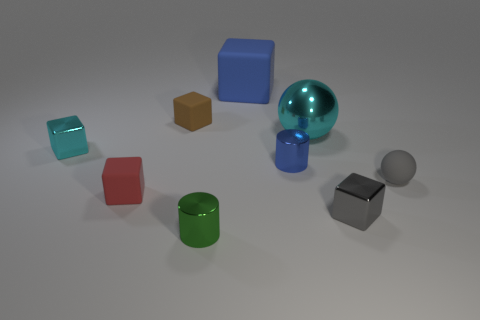What number of other things are the same shape as the tiny green object?
Provide a short and direct response. 1. Are there any other things that have the same color as the tiny ball?
Your answer should be compact. Yes. Is the color of the big block the same as the metal block that is on the left side of the brown thing?
Keep it short and to the point. No. What number of other objects are there of the same size as the green cylinder?
Provide a short and direct response. 6. What is the size of the metal cylinder that is the same color as the large cube?
Keep it short and to the point. Small. How many blocks are small red rubber objects or large metallic objects?
Keep it short and to the point. 1. Do the cyan shiny object left of the tiny green object and the big cyan shiny object have the same shape?
Ensure brevity in your answer.  No. Are there more tiny green metal cylinders that are behind the small red rubber cube than red rubber spheres?
Your answer should be very brief. No. What color is the sphere that is the same size as the blue cylinder?
Your answer should be very brief. Gray. What number of objects are either things that are on the right side of the tiny brown rubber object or small cyan matte spheres?
Your answer should be very brief. 6. 